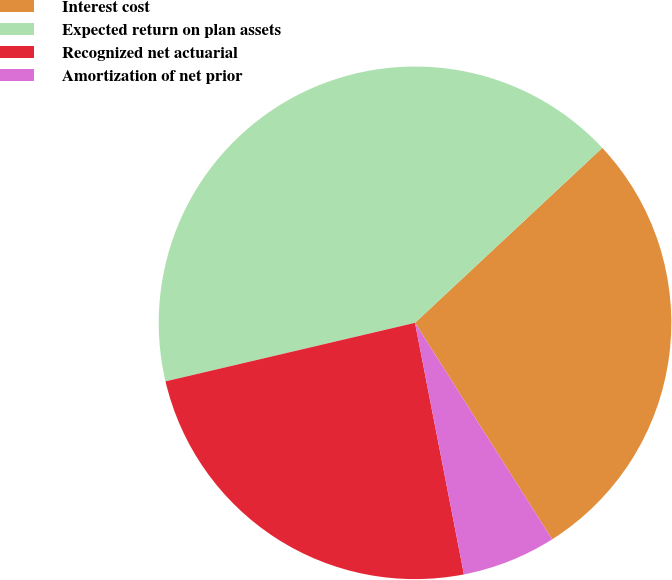Convert chart to OTSL. <chart><loc_0><loc_0><loc_500><loc_500><pie_chart><fcel>Interest cost<fcel>Expected return on plan assets<fcel>Recognized net actuarial<fcel>Amortization of net prior<nl><fcel>27.97%<fcel>41.71%<fcel>24.39%<fcel>5.93%<nl></chart> 